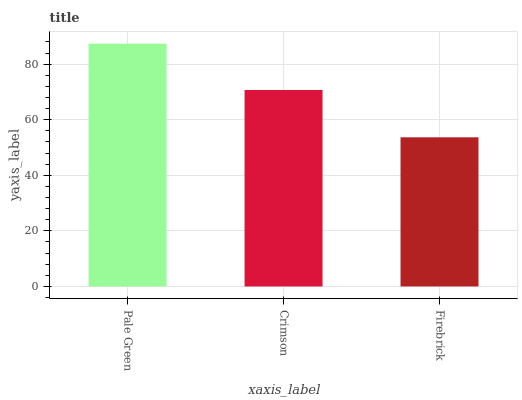Is Firebrick the minimum?
Answer yes or no. Yes. Is Pale Green the maximum?
Answer yes or no. Yes. Is Crimson the minimum?
Answer yes or no. No. Is Crimson the maximum?
Answer yes or no. No. Is Pale Green greater than Crimson?
Answer yes or no. Yes. Is Crimson less than Pale Green?
Answer yes or no. Yes. Is Crimson greater than Pale Green?
Answer yes or no. No. Is Pale Green less than Crimson?
Answer yes or no. No. Is Crimson the high median?
Answer yes or no. Yes. Is Crimson the low median?
Answer yes or no. Yes. Is Firebrick the high median?
Answer yes or no. No. Is Pale Green the low median?
Answer yes or no. No. 